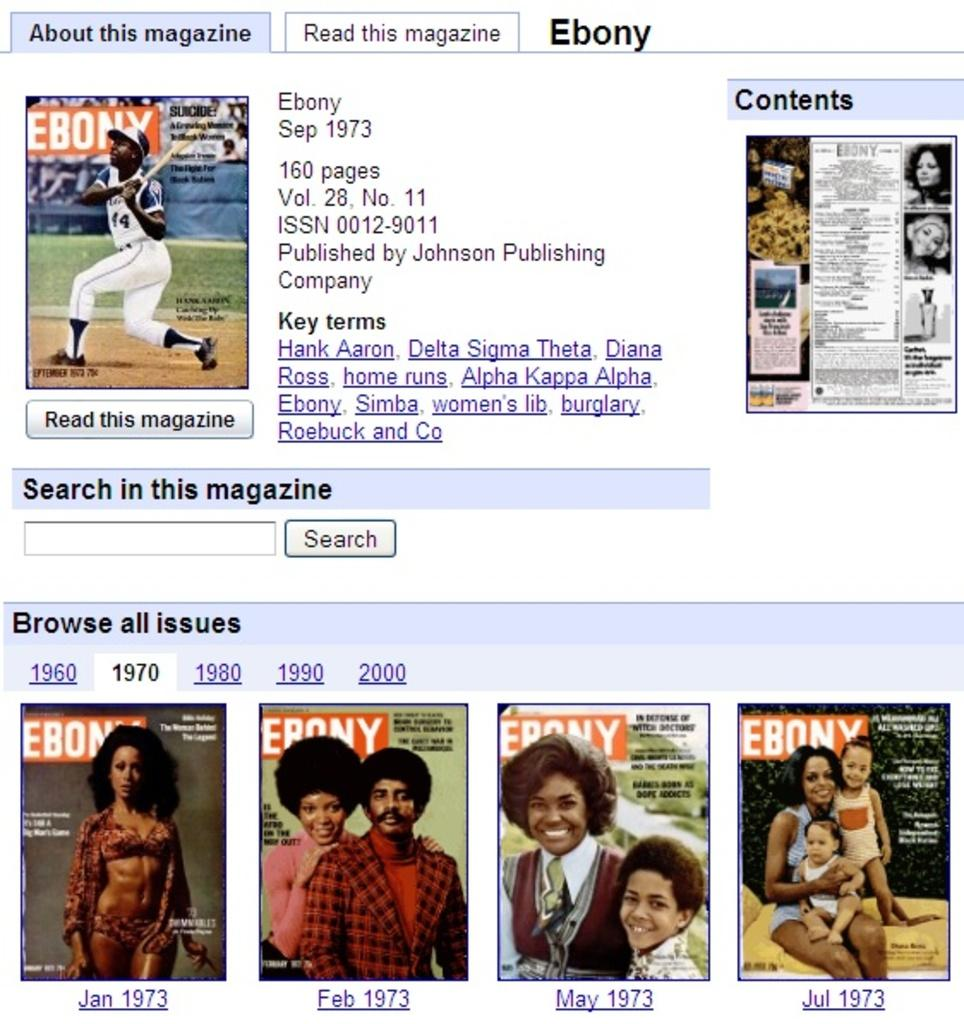What type of content is displayed on the web page? The image is a web page that contains posters, buttons, and text. What can be found on the posters? The posters contain images of people. What are the buttons used for on the web page? The buttons are used for interacting with the web page. What type of information is conveyed through the text on the web page? The text on the web page provides additional information or instructions. What type of fish can be seen swimming in the background of the web page? There are no fish present in the image, as it is a web page with posters, buttons, and text. 